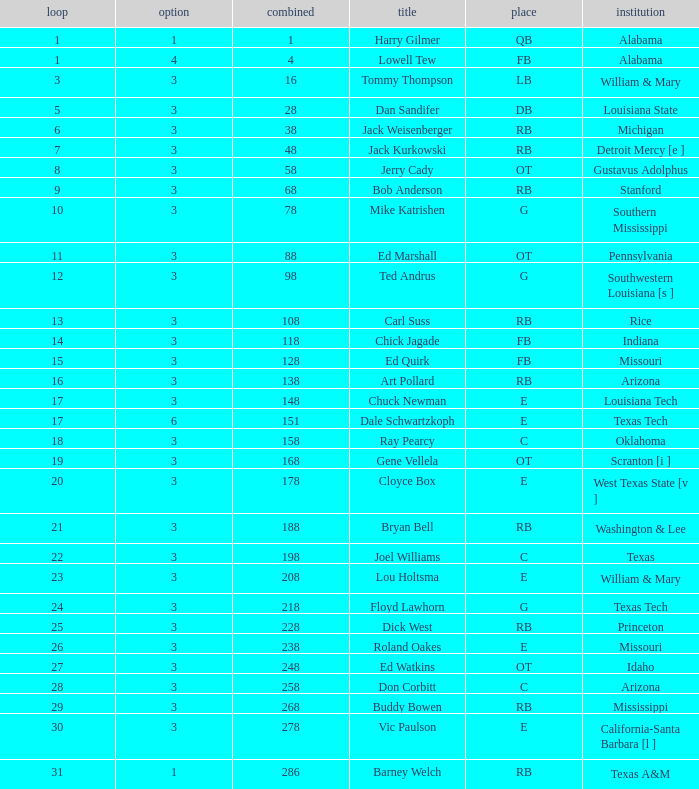Which pick has a Round smaller than 8, and an Overall smaller than 16, and a Name of harry gilmer? 1.0. 